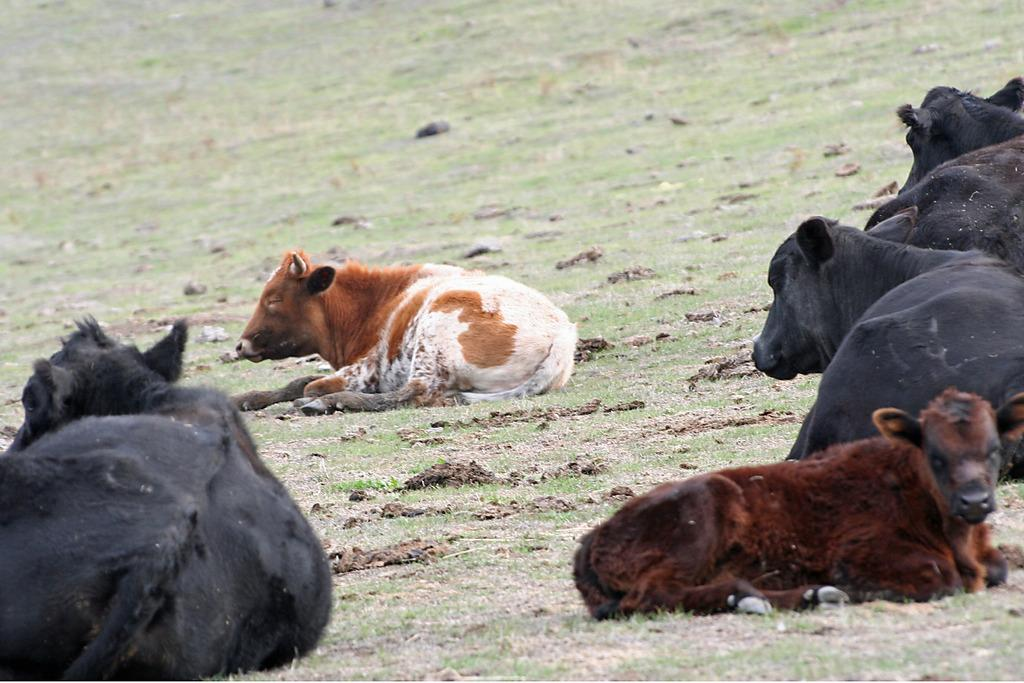What animals are present in the image? There are cows in the image. What position are the cows in? The cows are sitting on the ground. What type of surface is the ground covered with? The ground is covered with grass. Can you see a zebra standing next to the cows in the image? No, there is no zebra present in the image. 